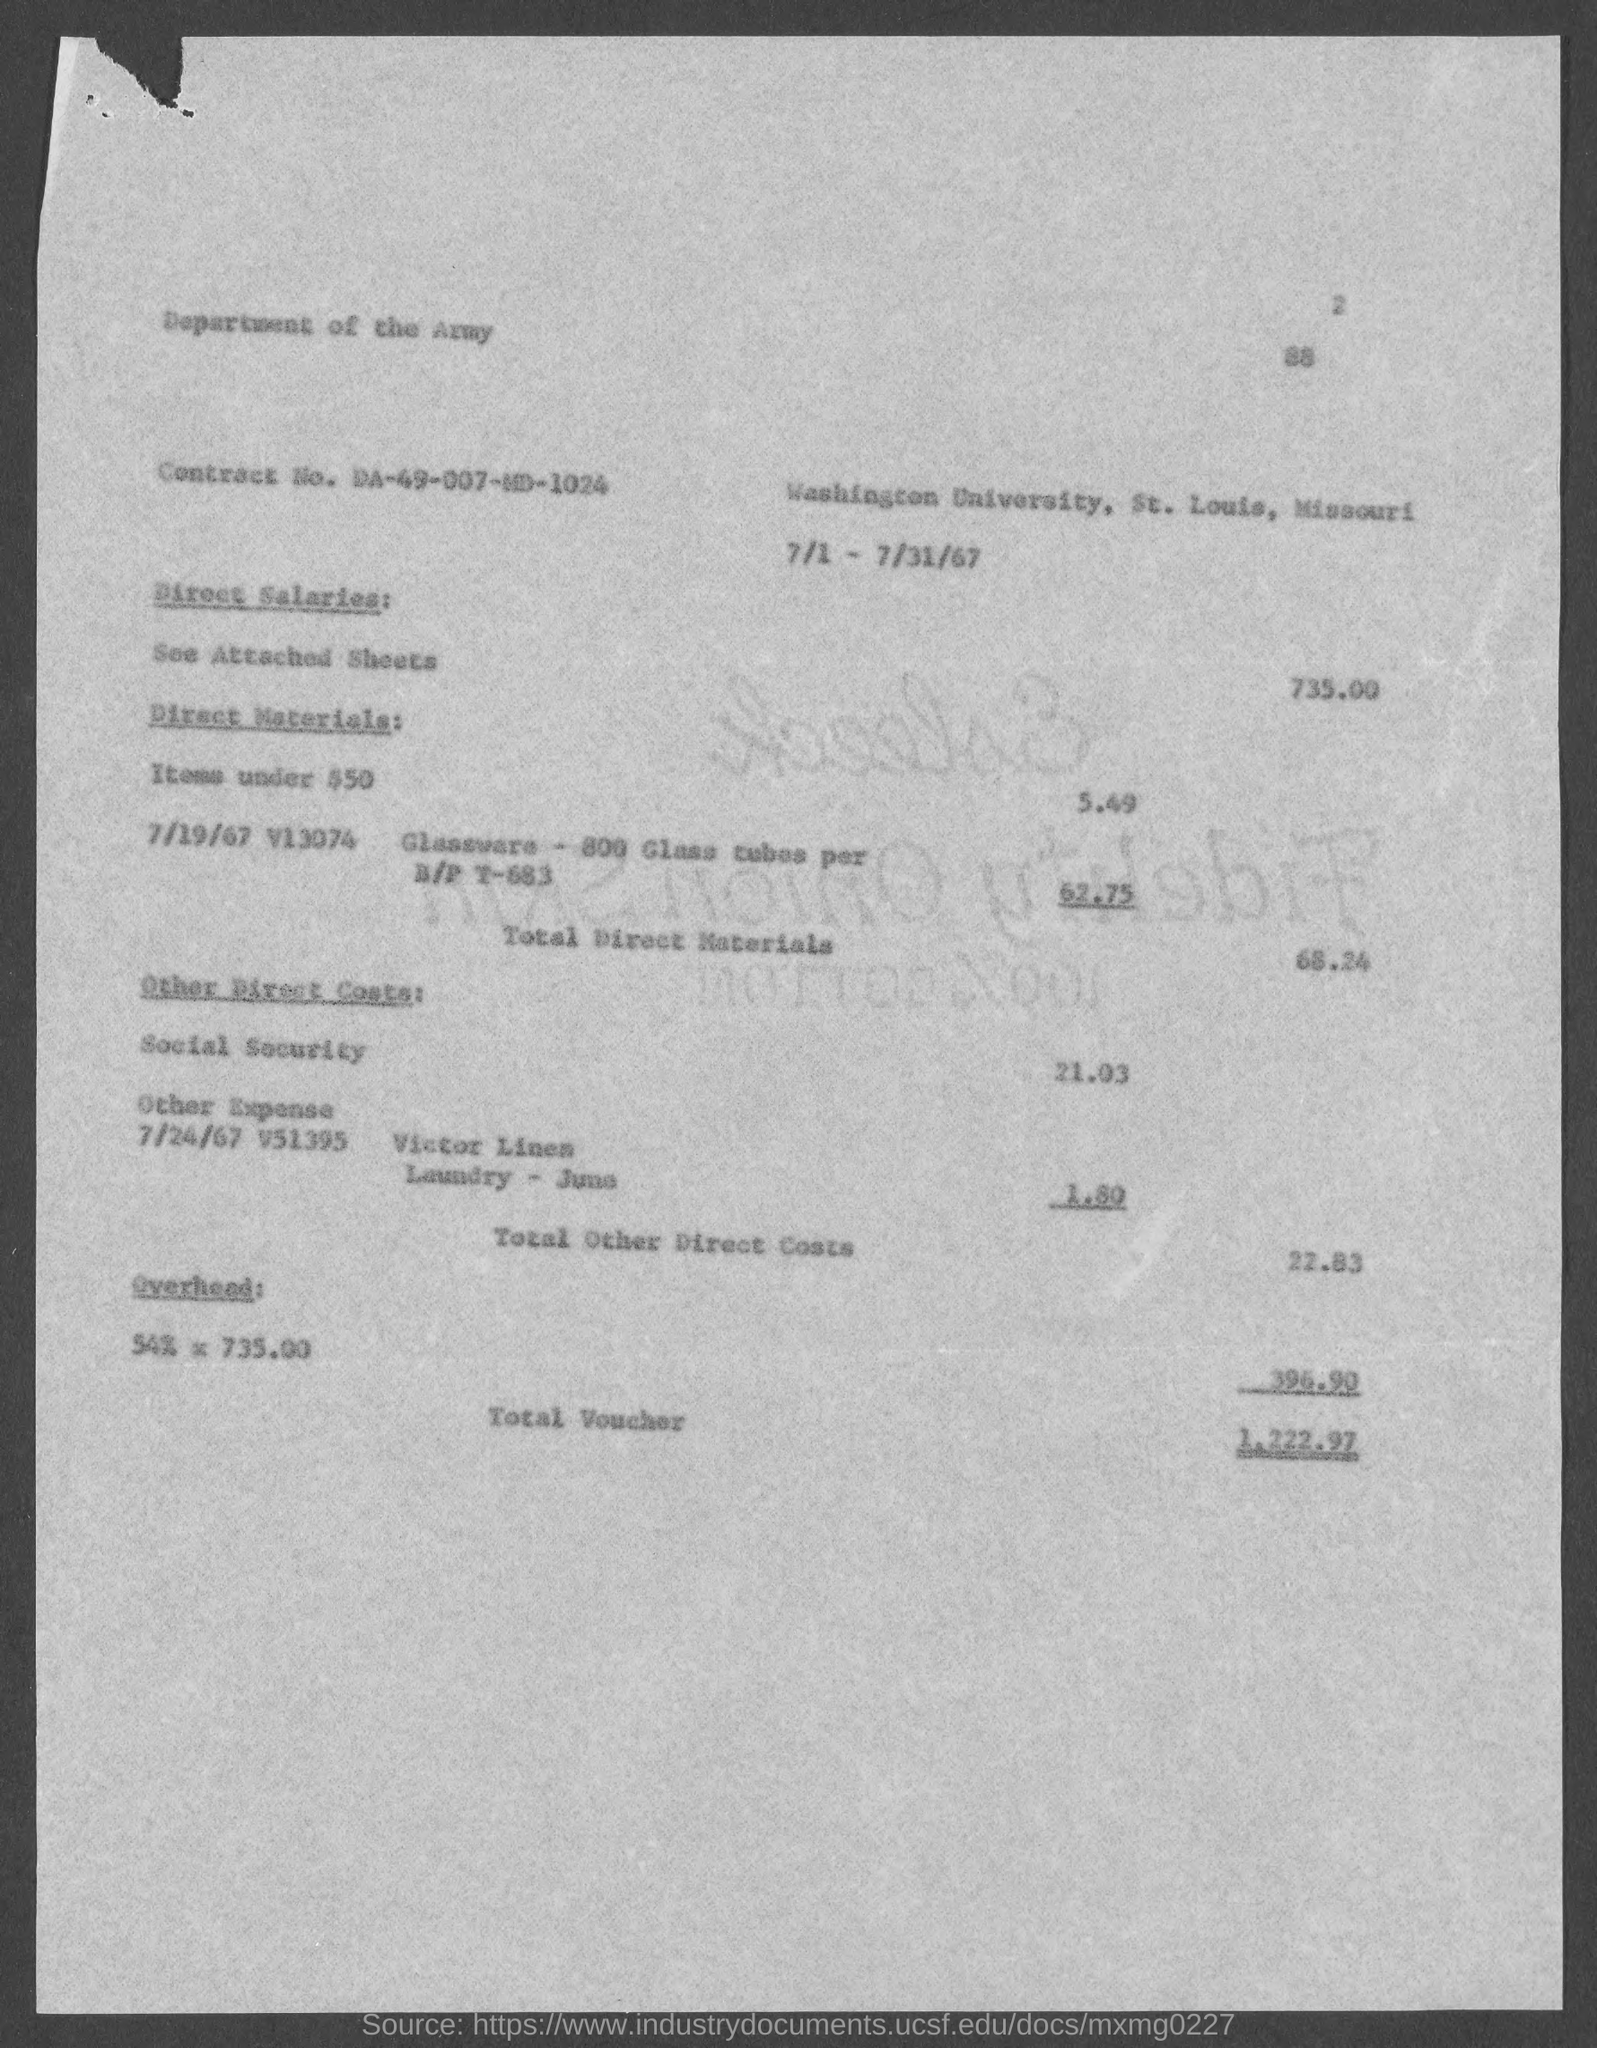Can you provide a breakdown of the different expenses that contribute to the total voucher amount? Certainly, the voucher includes Direct Salaries totaling $735.00, Direct Materials which sum to $66.24, and Other Direct Costs including Social Security at $21.03 and 'Victor Linen Laundry 3 Juns' at $1.80. The Overhead is listed as 54% of $735.00. These items accumulate to form the total voucher amount. 